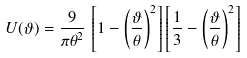<formula> <loc_0><loc_0><loc_500><loc_500>U ( \vartheta ) = \frac { 9 } { \pi \theta ^ { 2 } } \, \left [ 1 - \left ( \frac { \vartheta } { \theta } \right ) ^ { 2 } \right ] \left [ \frac { 1 } { 3 } - \left ( \frac { \vartheta } { \theta } \right ) ^ { 2 } \right ]</formula> 